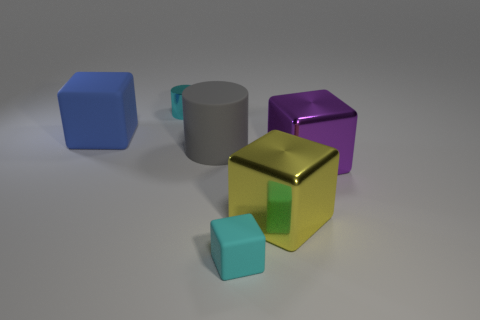What number of other tiny things are the same color as the tiny matte thing?
Give a very brief answer. 1. Is there any other thing that is the same shape as the blue thing?
Your answer should be very brief. Yes. There is another big matte thing that is the same shape as the purple object; what is its color?
Your answer should be compact. Blue. There is a big blue rubber thing; does it have the same shape as the small object that is behind the purple metal thing?
Your answer should be very brief. No. How many things are either cyan rubber things on the left side of the big purple block or tiny cyan objects that are in front of the small metal object?
Provide a short and direct response. 1. What is the material of the purple block?
Your answer should be very brief. Metal. What number of other objects are the same size as the cyan cylinder?
Give a very brief answer. 1. How big is the shiny cube in front of the big purple shiny object?
Provide a succinct answer. Large. There is a cylinder in front of the tiny object that is behind the cyan matte cube in front of the blue block; what is it made of?
Keep it short and to the point. Rubber. Is the shape of the large gray rubber object the same as the cyan metal thing?
Provide a succinct answer. Yes. 